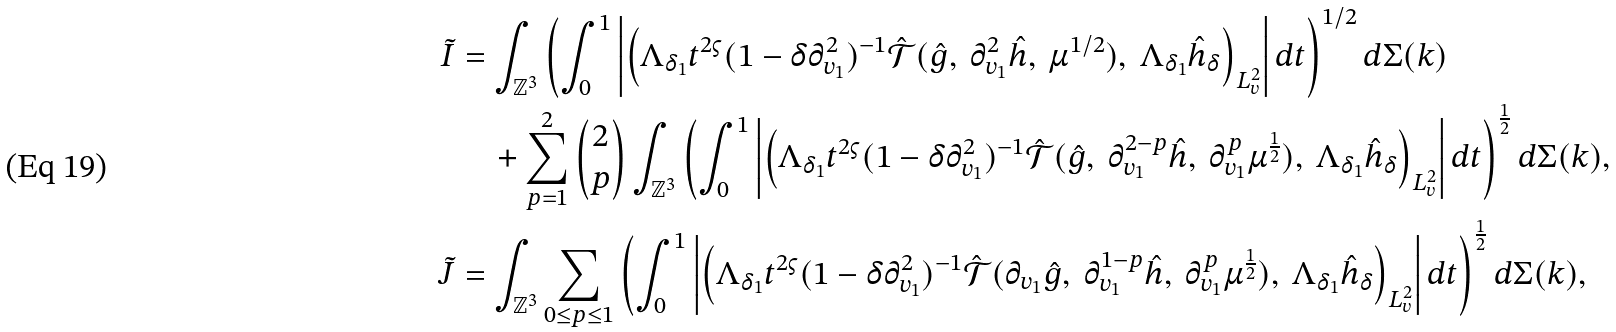Convert formula to latex. <formula><loc_0><loc_0><loc_500><loc_500>\tilde { I } & = \int _ { \mathbb { Z } ^ { 3 } } \left ( \int _ { 0 } ^ { 1 } \left | \left ( \Lambda _ { \delta _ { 1 } } t ^ { 2 \varsigma } ( 1 - \delta \partial _ { v _ { 1 } } ^ { 2 } ) ^ { - 1 } \hat { \mathcal { T } } ( \hat { g } , \ \partial _ { v _ { 1 } } ^ { 2 } \hat { h } , \ \mu ^ { 1 / 2 } ) , \ \Lambda _ { \delta _ { 1 } } \hat { h } _ { \delta } \right ) _ { L ^ { 2 } _ { v } } \right | d t \right ) ^ { 1 / 2 } d \Sigma ( k ) \\ & \quad + \sum _ { p = 1 } ^ { 2 } \begin{pmatrix} 2 \\ p \end{pmatrix} \int _ { \mathbb { Z } ^ { 3 } } \left ( \int _ { 0 } ^ { 1 } \left | \left ( \Lambda _ { \delta _ { 1 } } t ^ { 2 \varsigma } ( 1 - \delta \partial _ { v _ { 1 } } ^ { 2 } ) ^ { - 1 } \hat { \mathcal { T } } ( \hat { g } , \ \partial _ { v _ { 1 } } ^ { 2 - p } \hat { h } , \ \partial _ { v _ { 1 } } ^ { p } \mu ^ { \frac { 1 } { 2 } } ) , \ \Lambda _ { \delta _ { 1 } } \hat { h } _ { \delta } \right ) _ { L ^ { 2 } _ { v } } \right | d t \right ) ^ { \frac { 1 } { 2 } } d \Sigma ( k ) , \\ \tilde { J } & = \int _ { \mathbb { Z } ^ { 3 } } \sum _ { 0 \leq p \leq 1 } \left ( \int _ { 0 } ^ { 1 } \left | \left ( \Lambda _ { \delta _ { 1 } } t ^ { 2 \varsigma } ( 1 - \delta \partial _ { v _ { 1 } } ^ { 2 } ) ^ { - 1 } \hat { \mathcal { T } } ( \partial _ { v _ { 1 } } \hat { g } , \ \partial _ { v _ { 1 } } ^ { 1 - p } \hat { h } , \ \partial _ { v _ { 1 } } ^ { p } \mu ^ { \frac { 1 } { 2 } } ) , \ \Lambda _ { \delta _ { 1 } } \hat { h } _ { \delta } \right ) _ { L ^ { 2 } _ { v } } \right | d t \right ) ^ { \frac { 1 } { 2 } } d \Sigma ( k ) ,</formula> 